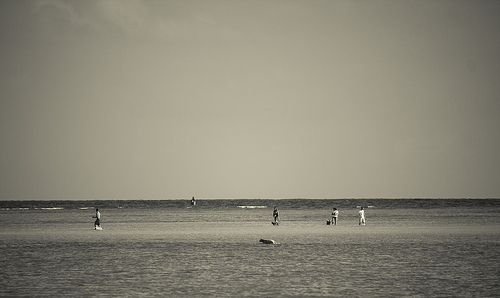a person in walking. An accurate depiction for a person in motion would capture their stride and position on the beach, often shown towards the edge of a scene for a sense of movement. 